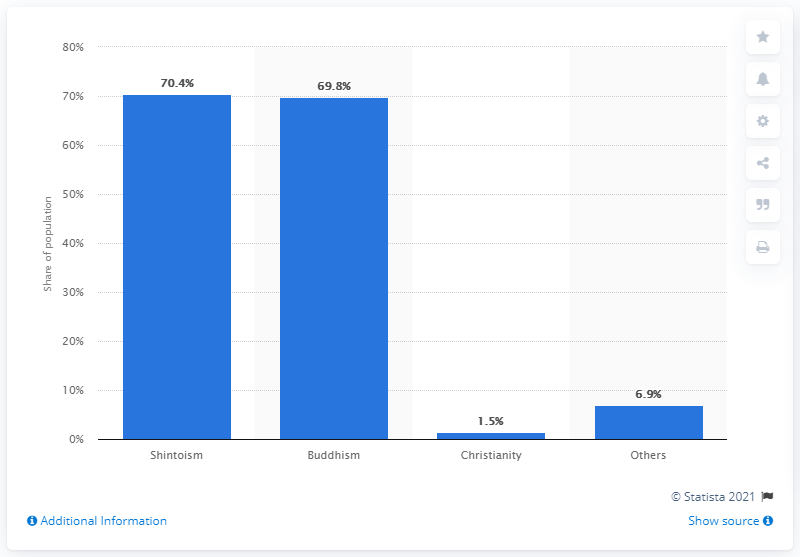Highlight a few significant elements in this photo. In 2017, approximately 70.4% of Japan's population participated in Shintoism. Shintoism is the traditional Japanese religion that emphasizes rituals and worship at shrines. Buddhism is the religion that is closely behind Shintoism in terms of popularity and influence in Japan. 